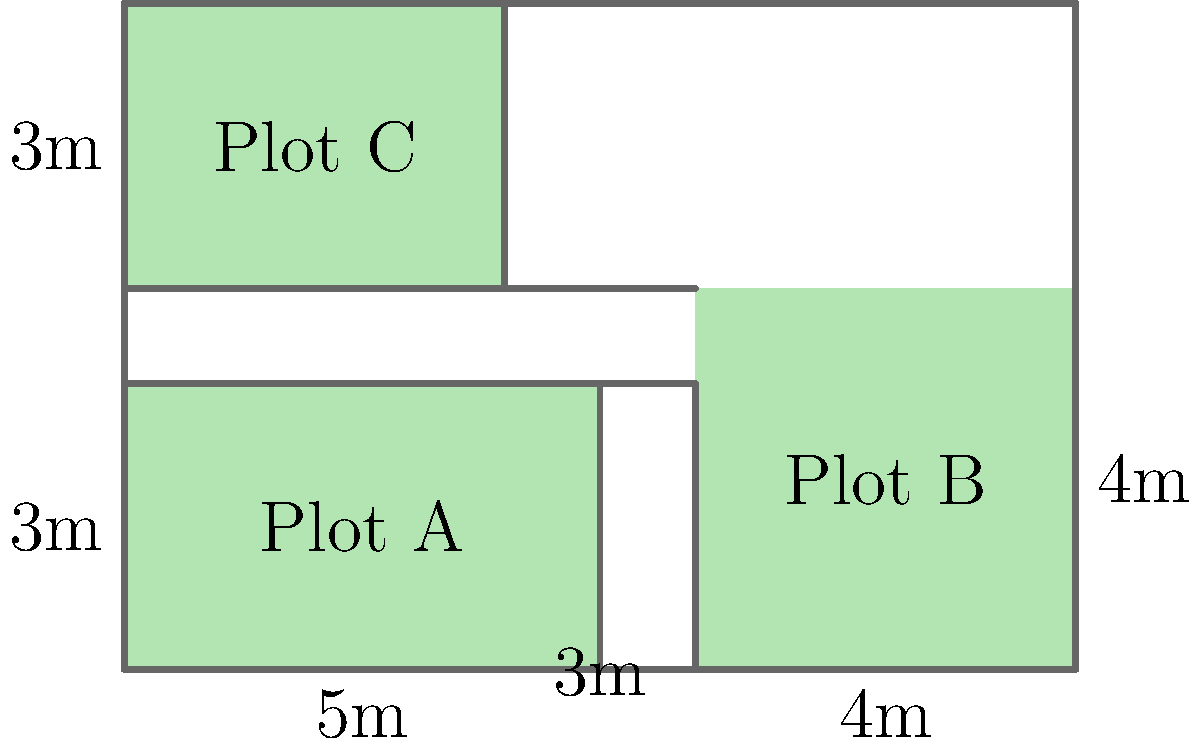As a field officer at a conservation center, you're tasked with calculating the total length of fencing needed to enclose three rectangular plots for different species. Plot A measures 5m by 3m, Plot B is 4m by 4m, and Plot C is 4m by 3m. The plots are arranged as shown in the diagram, with no space between adjacent plots. What is the total length of fencing required to enclose all three plots together? To solve this problem, we need to calculate the perimeter of the entire enclosed area. Let's approach this step-by-step:

1. First, we need to determine the overall dimensions of the combined plots:
   - Width: Plot A (5m) + Plot B (4m) = 9m total width
   - Height: Plot A/B height (4m) + Plot C height (3m) = 7m total height

2. Now that we have the overall dimensions, we can calculate the perimeter:
   $$ \text{Perimeter} = 2 \times (\text{width} + \text{height}) $$
   $$ \text{Perimeter} = 2 \times (9\text{m} + 7\text{m}) $$
   $$ \text{Perimeter} = 2 \times 16\text{m} $$
   $$ \text{Perimeter} = 32\text{m} $$

3. Therefore, the total length of fencing required to enclose all three plots is 32 meters.

This approach saves fencing material by using a single enclosure for all three plots rather than fencing each plot individually.
Answer: 32 meters 